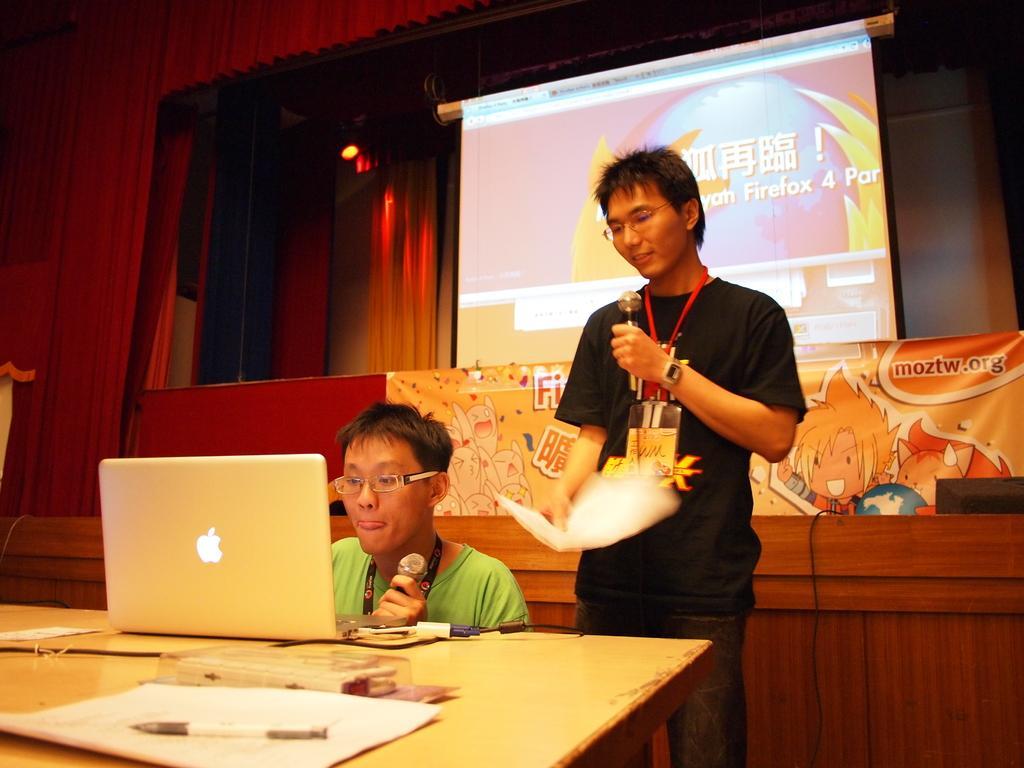Could you give a brief overview of what you see in this image? The person wearing green dress is operating a mac book which is placed on the table and there is another person standing behind him and the background is red and there is also a projector in the background. 